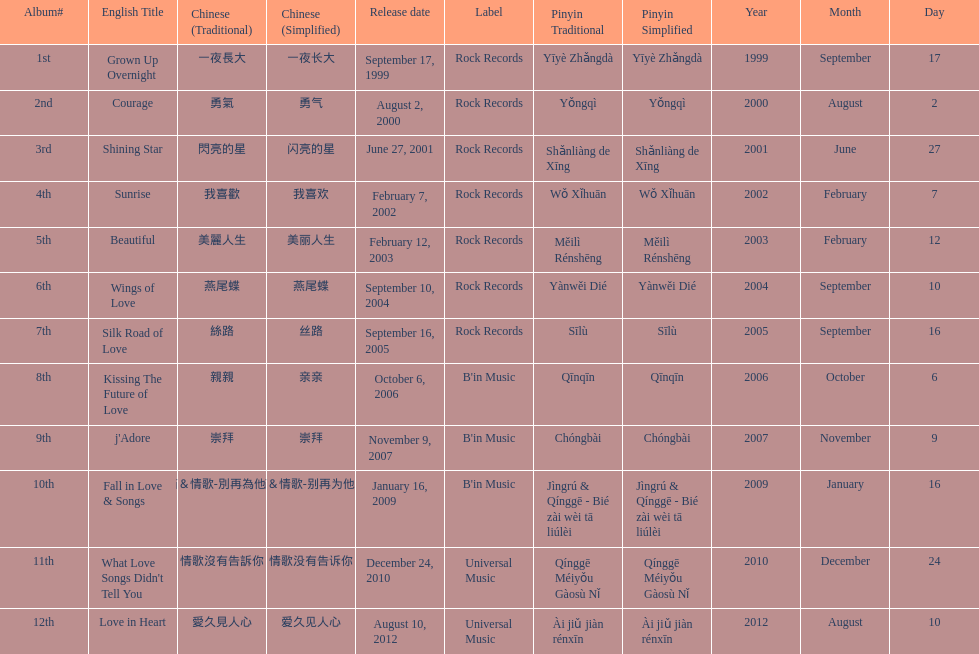What is the name of her last album produced with rock records? Silk Road of Love. 